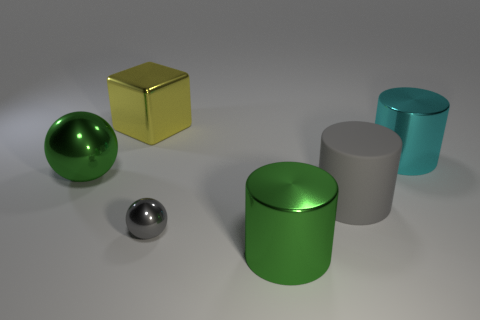Are any cyan metal things visible?
Your answer should be compact. Yes. What number of other things are the same size as the green ball?
Your response must be concise. 4. There is a tiny shiny thing; is it the same color as the big thing to the left of the large yellow metallic cube?
Make the answer very short. No. How many things are big gray rubber things or balls?
Your answer should be compact. 3. Are there any other things that are the same color as the matte cylinder?
Give a very brief answer. Yes. Are the large cyan thing and the green object that is on the left side of the large yellow metal block made of the same material?
Provide a succinct answer. Yes. What shape is the large green thing on the left side of the green object on the right side of the large block?
Provide a short and direct response. Sphere. What shape is the object that is both to the left of the tiny gray metal thing and in front of the yellow metallic thing?
Offer a very short reply. Sphere. How many objects are big rubber objects or big green objects that are behind the gray matte cylinder?
Ensure brevity in your answer.  2. There is a big green object that is the same shape as the cyan metallic thing; what is its material?
Make the answer very short. Metal. 